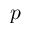<formula> <loc_0><loc_0><loc_500><loc_500>p</formula> 